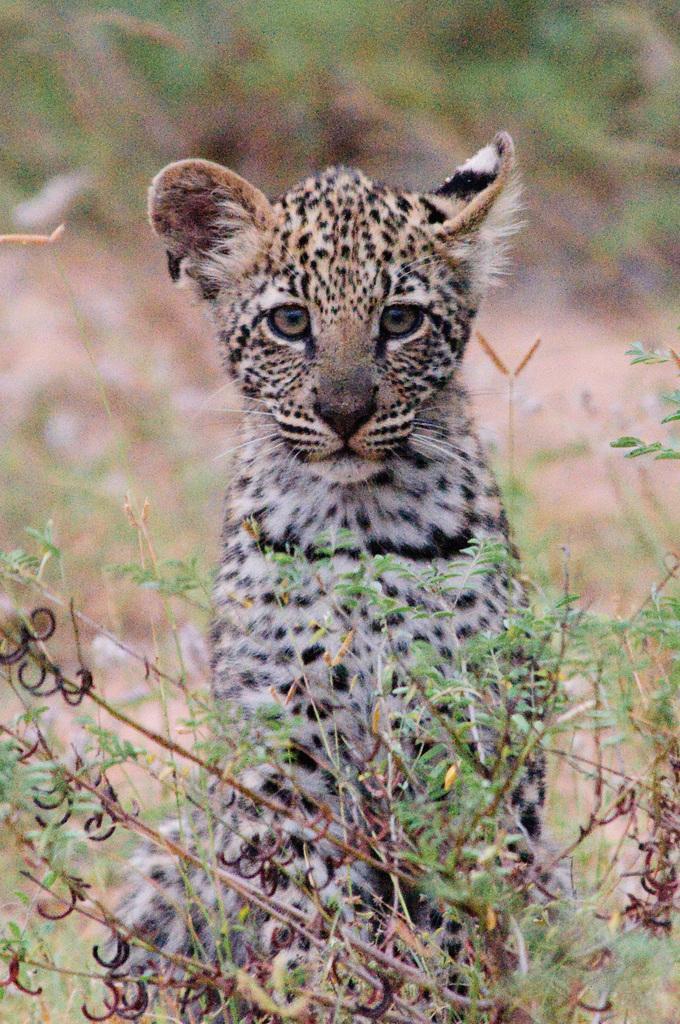In one or two sentences, can you explain what this image depicts? In this image we can see a leopard cub. Also there are stems with leaves. In the background it is blur. 